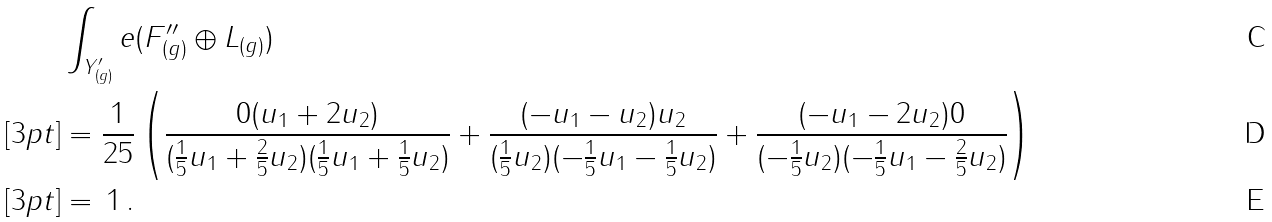Convert formula to latex. <formula><loc_0><loc_0><loc_500><loc_500>& \int _ { Y _ { ( g ) } ^ { \prime } } e ( F _ { ( g ) } ^ { \prime \prime } \oplus L _ { ( g ) } ) \\ [ 3 p t ] & = \frac { 1 } { 2 5 } \left ( \frac { 0 ( u _ { 1 } + 2 u _ { 2 } ) } { ( \frac { 1 } { 5 } u _ { 1 } + \frac { 2 } { 5 } u _ { 2 } ) ( \frac { 1 } { 5 } u _ { 1 } + \frac { 1 } { 5 } u _ { 2 } ) } + \frac { ( - u _ { 1 } - u _ { 2 } ) u _ { 2 } } { ( \frac { 1 } { 5 } u _ { 2 } ) ( - \frac { 1 } { 5 } u _ { 1 } - \frac { 1 } { 5 } u _ { 2 } ) } + \frac { ( - u _ { 1 } - 2 u _ { 2 } ) 0 } { ( - \frac { 1 } { 5 } u _ { 2 } ) ( - \frac { 1 } { 5 } u _ { 1 } - \frac { 2 } { 5 } u _ { 2 } ) } \right ) \\ [ 3 p t ] & = \, 1 \, .</formula> 